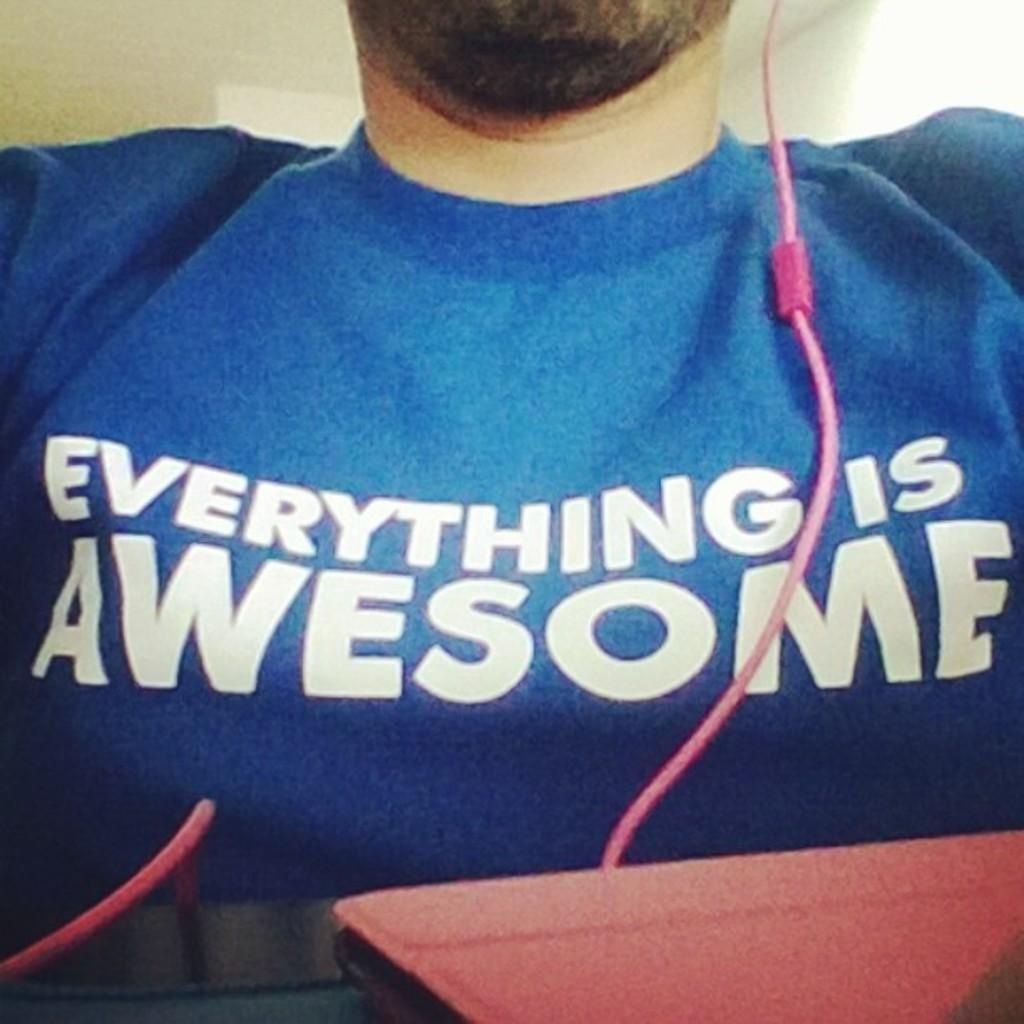<image>
Present a compact description of the photo's key features. A closeup of a man wearing a blue shirt reading EVERYTHING IS AWESOME. 